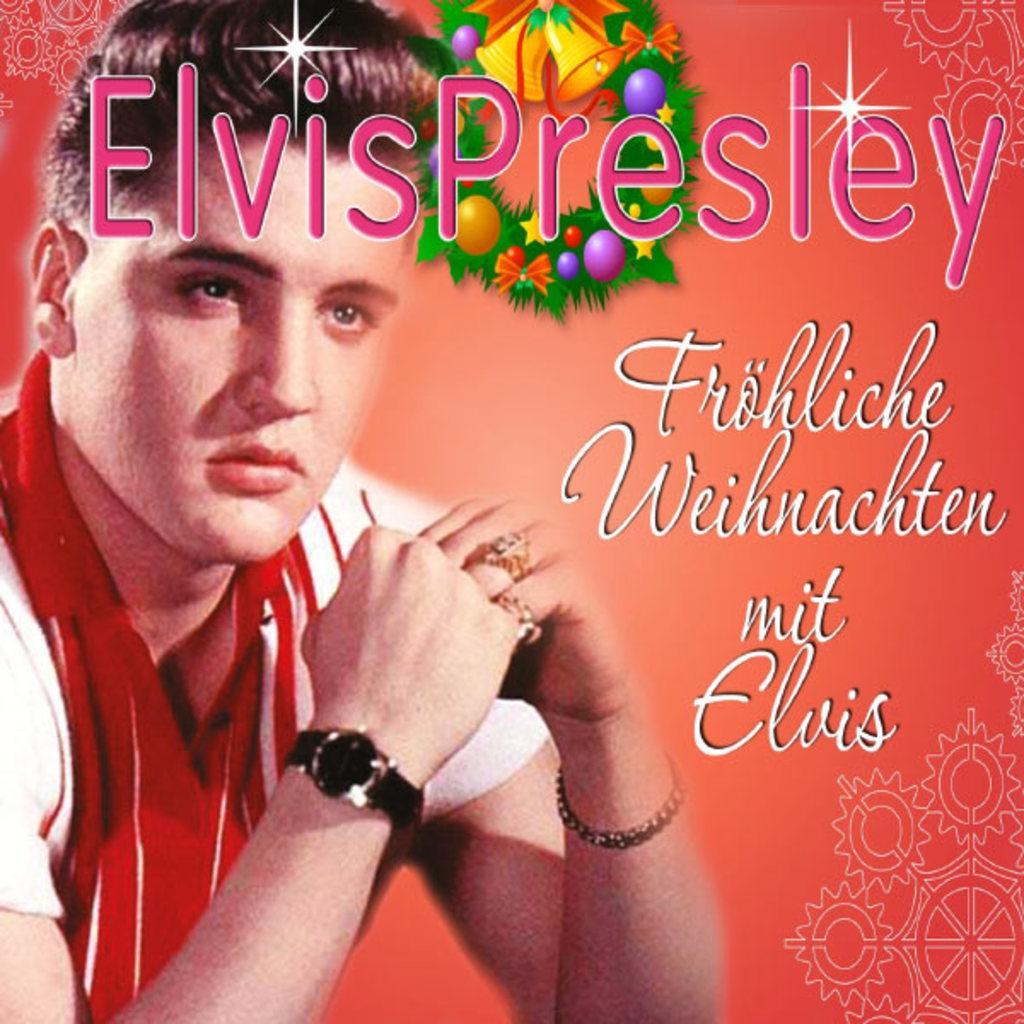Could you give a brief overview of what you see in this image? In this image I can see the poster. In the poster I can see the person wearing the red and white color dress. And I can see something is written on it. 